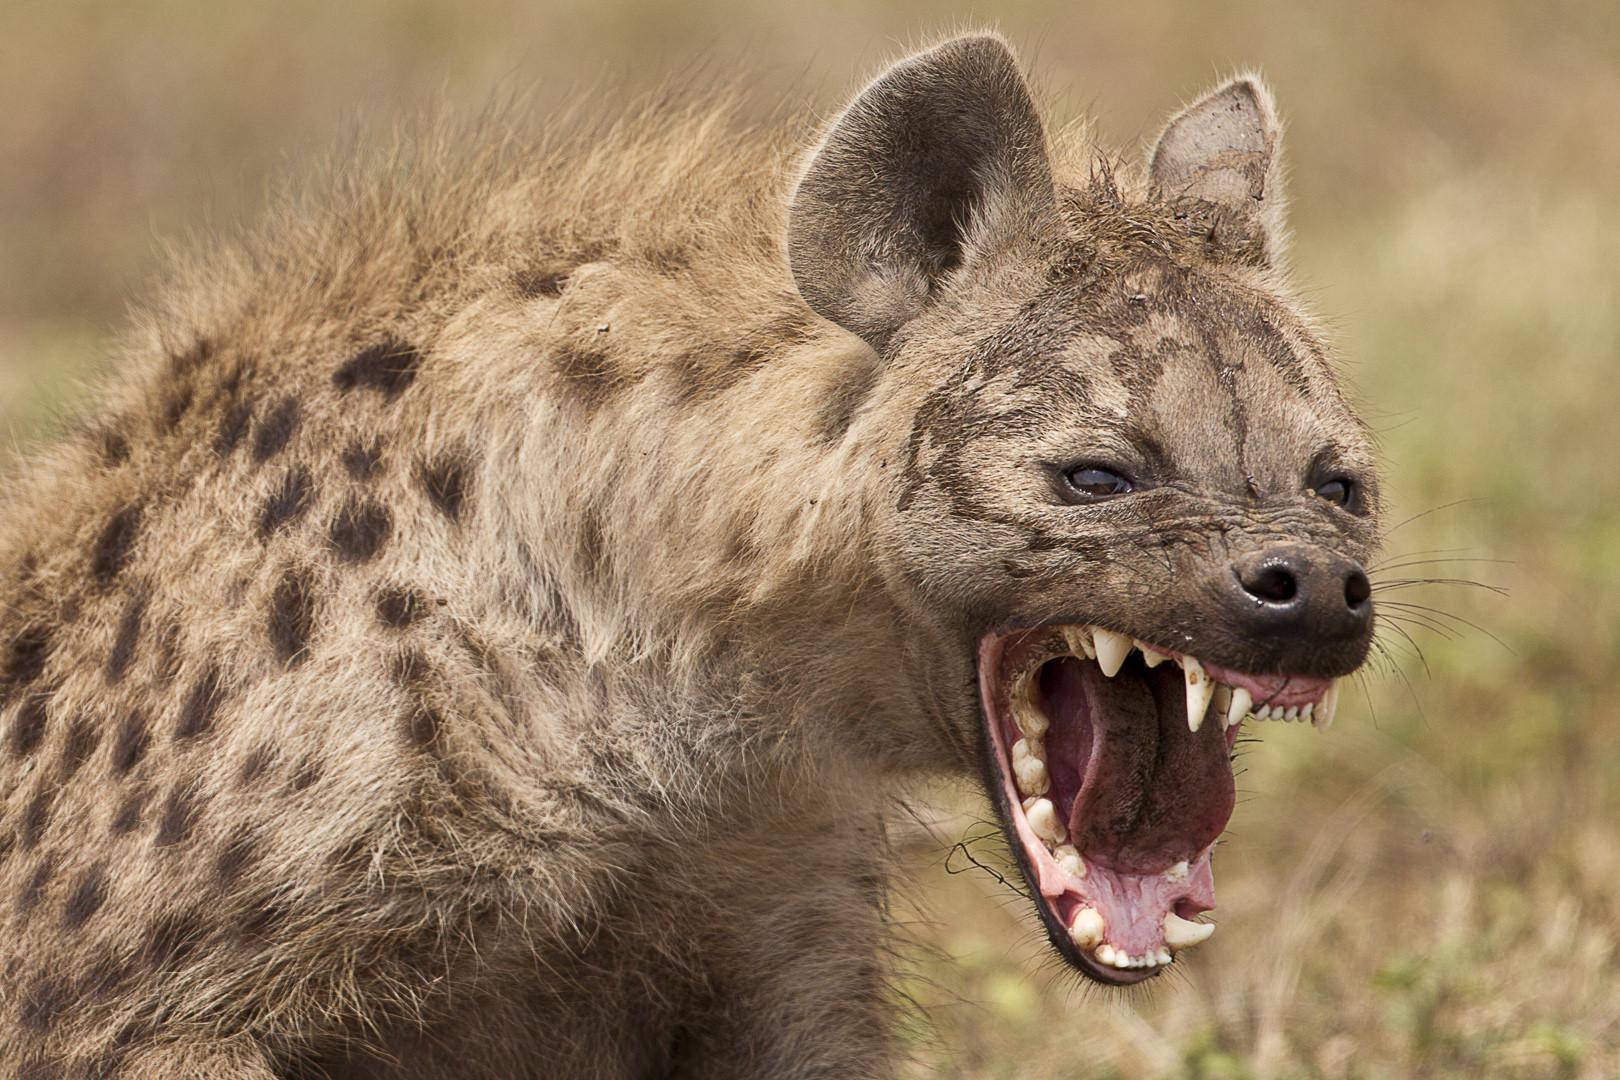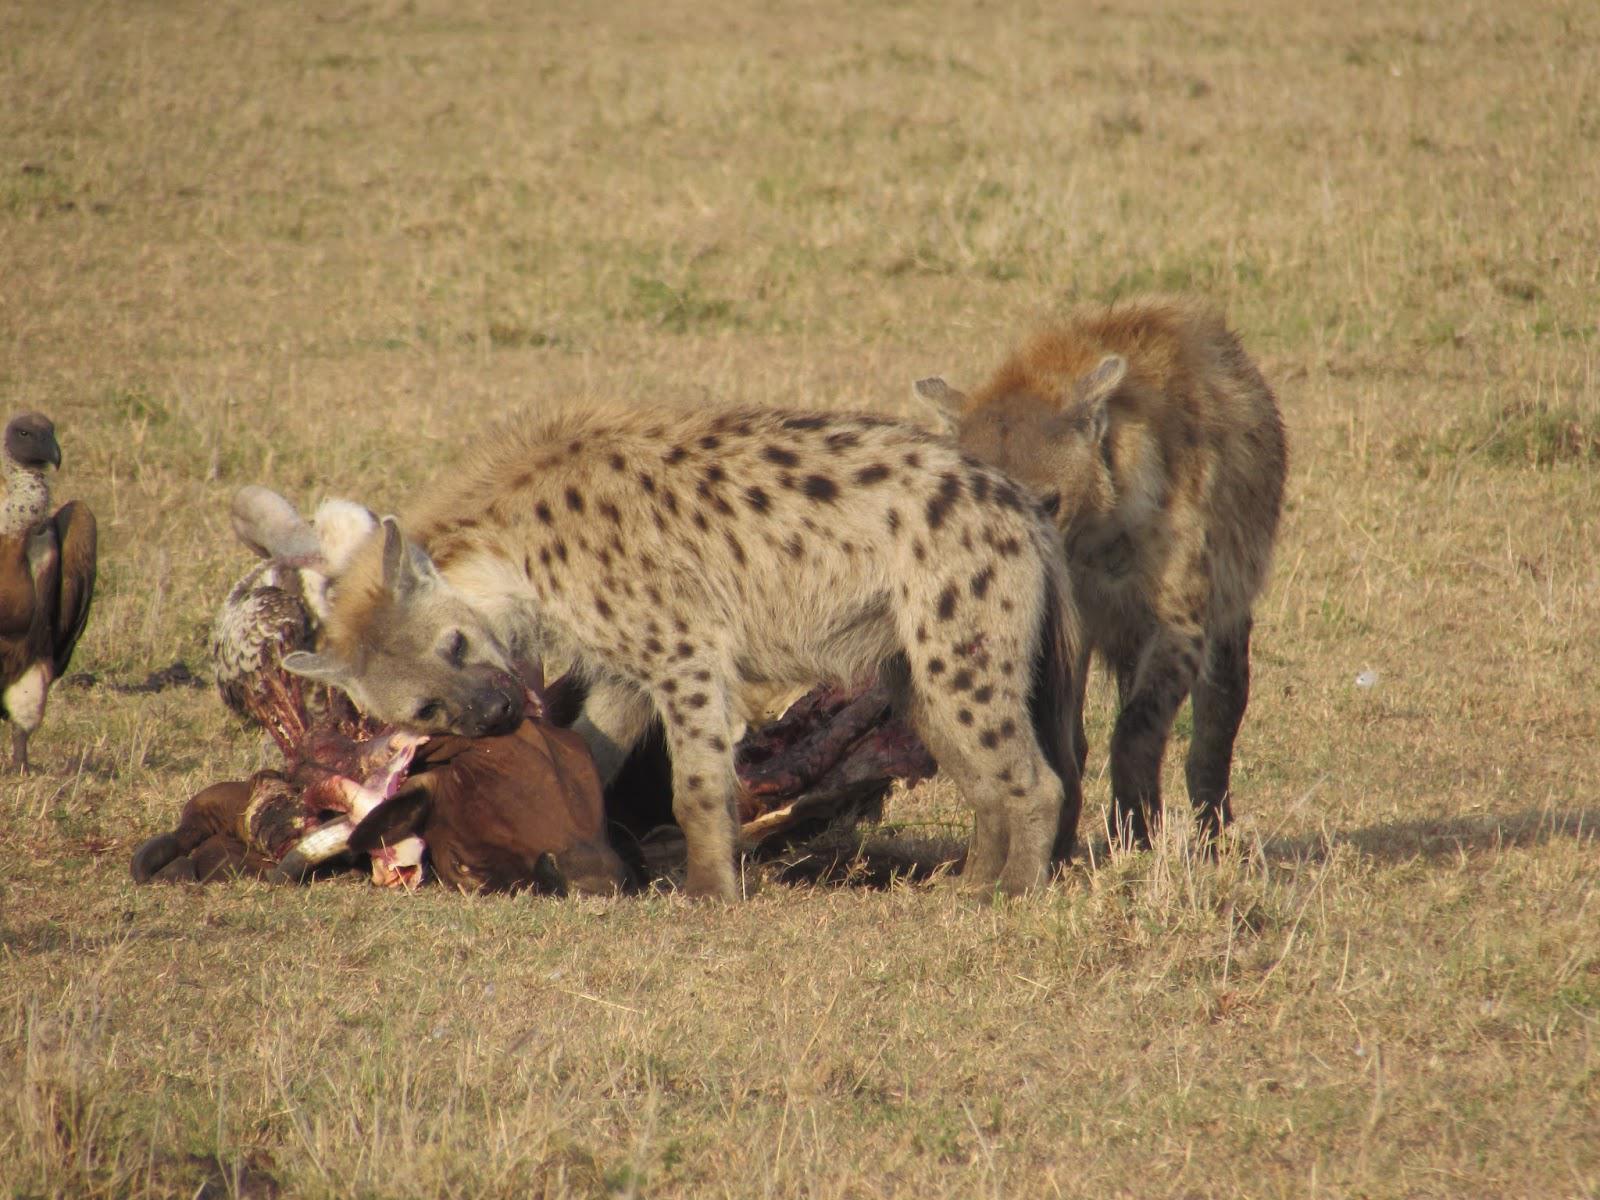The first image is the image on the left, the second image is the image on the right. For the images shown, is this caption "One standing animal with a black nose is looking forward in the right image." true? Answer yes or no. No. The first image is the image on the left, the second image is the image on the right. For the images displayed, is the sentence "The image on the left shows 2 animals both looking in the same direction." factually correct? Answer yes or no. No. 